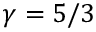Convert formula to latex. <formula><loc_0><loc_0><loc_500><loc_500>\gamma = 5 / 3</formula> 